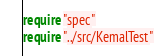Convert code to text. <code><loc_0><loc_0><loc_500><loc_500><_Crystal_>require "spec"
require "../src/KemalTest"
</code> 